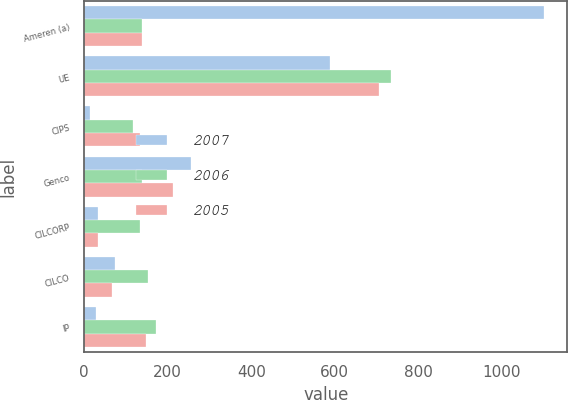Convert chart. <chart><loc_0><loc_0><loc_500><loc_500><stacked_bar_chart><ecel><fcel>Ameren (a)<fcel>UE<fcel>CIPS<fcel>Genco<fcel>CILCORP<fcel>CILCO<fcel>IP<nl><fcel>2007<fcel>1102<fcel>588<fcel>14<fcel>255<fcel>33<fcel>74<fcel>28<nl><fcel>2006<fcel>138<fcel>734<fcel>118<fcel>138<fcel>133<fcel>153<fcel>172<nl><fcel>2005<fcel>138<fcel>706<fcel>133<fcel>213<fcel>33<fcel>67<fcel>148<nl></chart> 